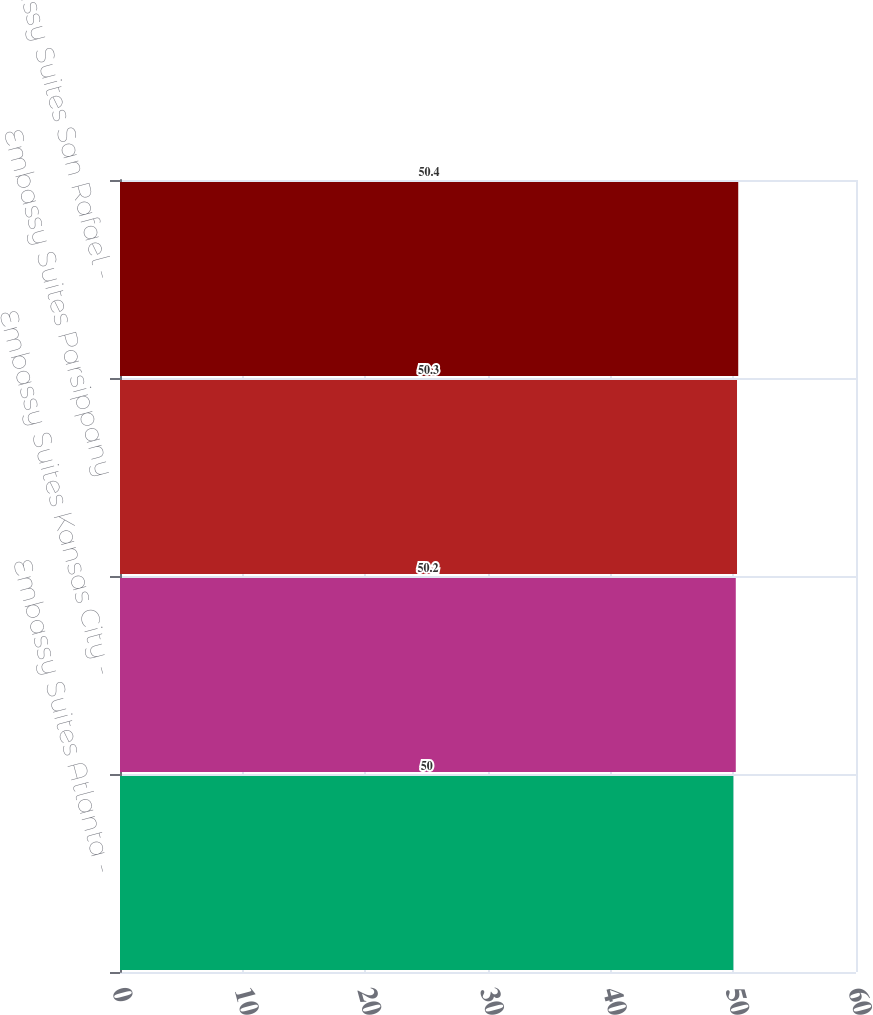Convert chart to OTSL. <chart><loc_0><loc_0><loc_500><loc_500><bar_chart><fcel>Embassy Suites Atlanta -<fcel>Embassy Suites Kansas City -<fcel>Embassy Suites Parsippany<fcel>Embassy Suites San Rafael -<nl><fcel>50<fcel>50.2<fcel>50.3<fcel>50.4<nl></chart> 